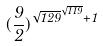Convert formula to latex. <formula><loc_0><loc_0><loc_500><loc_500>( \frac { 9 } { 2 } ) ^ { \sqrt { 1 2 9 } ^ { \sqrt { 1 1 9 } } + 1 }</formula> 